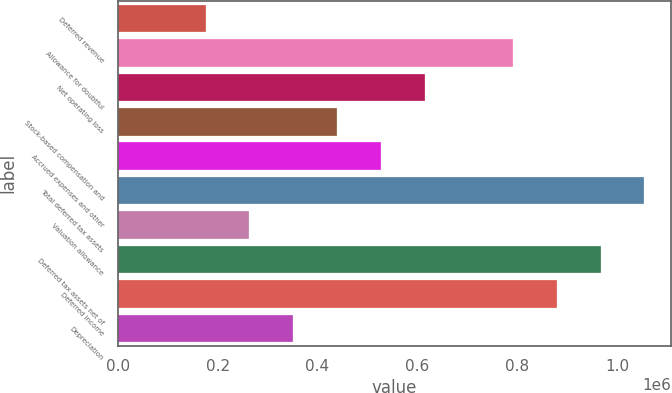Convert chart. <chart><loc_0><loc_0><loc_500><loc_500><bar_chart><fcel>Deferred revenue<fcel>Allowance for doubtful<fcel>Net operating loss<fcel>Stock-based compensation and<fcel>Accrued expenses and other<fcel>Total deferred tax assets<fcel>Valuation allowance<fcel>Deferred tax assets net of<fcel>Deferred income<fcel>Depreciation<nl><fcel>175880<fcel>790884<fcel>615169<fcel>439453<fcel>527311<fcel>1.05446e+06<fcel>263737<fcel>966600<fcel>878742<fcel>351595<nl></chart> 